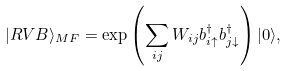Convert formula to latex. <formula><loc_0><loc_0><loc_500><loc_500>| R V B \rangle _ { M F } = \exp \left ( \sum _ { i j } W _ { i j } b _ { i \uparrow } ^ { \dagger } b _ { j \downarrow } ^ { \dagger } \right ) | 0 \rangle ,</formula> 